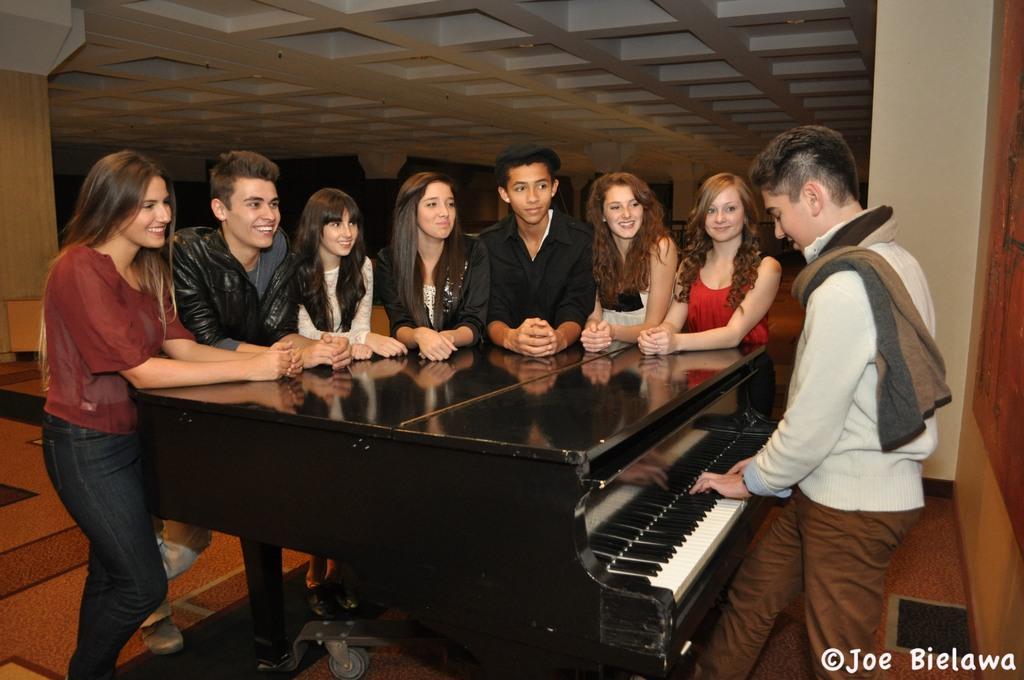How would you summarize this image in a sentence or two? In this picture we can see a group of people standing and smiling and looking at the person where he is playing piano and in the background we can see pillar, wall. 